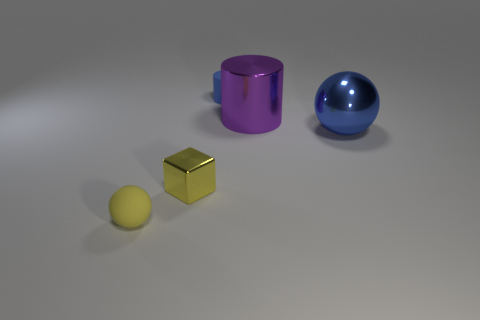Is there any other thing that is the same size as the shiny cube?
Ensure brevity in your answer.  Yes. What number of other objects are there of the same color as the shiny cylinder?
Your answer should be compact. 0. What number of cubes are large metal objects or gray metal objects?
Make the answer very short. 0. What color is the small rubber thing that is to the left of the blue object left of the large purple object?
Ensure brevity in your answer.  Yellow. What shape is the big purple shiny object?
Give a very brief answer. Cylinder. There is a thing that is to the left of the yellow metal thing; does it have the same size as the large purple object?
Your answer should be compact. No. Are there any tiny yellow things made of the same material as the tiny yellow block?
Your answer should be very brief. No. How many things are either things on the left side of the shiny cube or large blue spheres?
Provide a short and direct response. 2. Is there a green thing?
Ensure brevity in your answer.  No. What is the shape of the small thing that is both in front of the purple metal thing and behind the small rubber ball?
Give a very brief answer. Cube. 